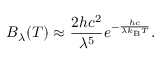<formula> <loc_0><loc_0><loc_500><loc_500>B _ { \lambda } ( T ) \approx { \frac { 2 h c ^ { 2 } } { \lambda ^ { 5 } } } e ^ { - { \frac { h c } { \lambda k _ { B } T } } } .</formula> 